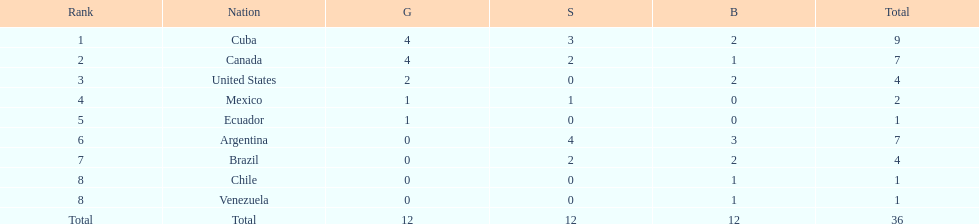How many total medals did argentina win? 7. 